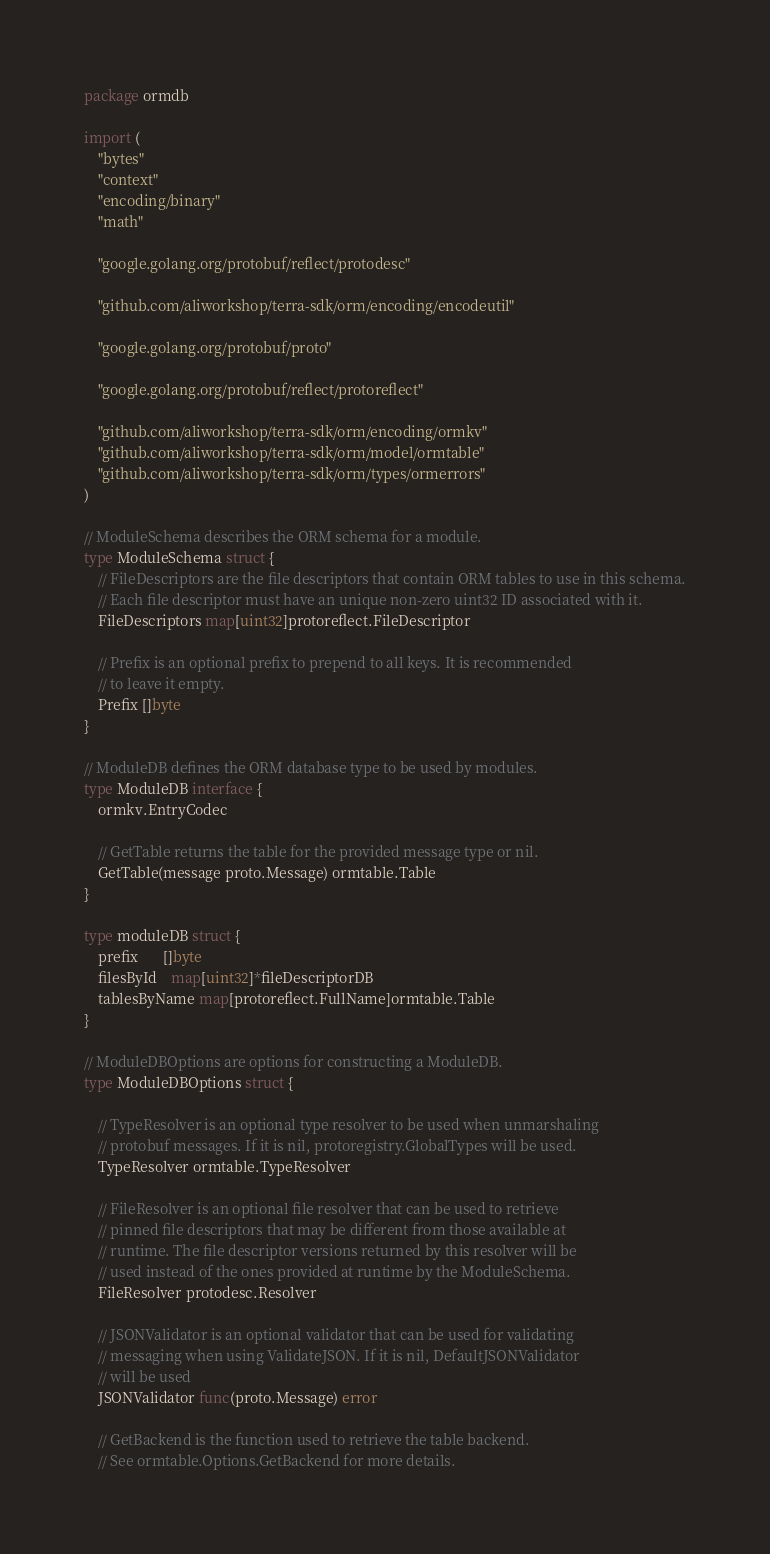<code> <loc_0><loc_0><loc_500><loc_500><_Go_>package ormdb

import (
	"bytes"
	"context"
	"encoding/binary"
	"math"

	"google.golang.org/protobuf/reflect/protodesc"

	"github.com/aliworkshop/terra-sdk/orm/encoding/encodeutil"

	"google.golang.org/protobuf/proto"

	"google.golang.org/protobuf/reflect/protoreflect"

	"github.com/aliworkshop/terra-sdk/orm/encoding/ormkv"
	"github.com/aliworkshop/terra-sdk/orm/model/ormtable"
	"github.com/aliworkshop/terra-sdk/orm/types/ormerrors"
)

// ModuleSchema describes the ORM schema for a module.
type ModuleSchema struct {
	// FileDescriptors are the file descriptors that contain ORM tables to use in this schema.
	// Each file descriptor must have an unique non-zero uint32 ID associated with it.
	FileDescriptors map[uint32]protoreflect.FileDescriptor

	// Prefix is an optional prefix to prepend to all keys. It is recommended
	// to leave it empty.
	Prefix []byte
}

// ModuleDB defines the ORM database type to be used by modules.
type ModuleDB interface {
	ormkv.EntryCodec

	// GetTable returns the table for the provided message type or nil.
	GetTable(message proto.Message) ormtable.Table
}

type moduleDB struct {
	prefix       []byte
	filesById    map[uint32]*fileDescriptorDB
	tablesByName map[protoreflect.FullName]ormtable.Table
}

// ModuleDBOptions are options for constructing a ModuleDB.
type ModuleDBOptions struct {

	// TypeResolver is an optional type resolver to be used when unmarshaling
	// protobuf messages. If it is nil, protoregistry.GlobalTypes will be used.
	TypeResolver ormtable.TypeResolver

	// FileResolver is an optional file resolver that can be used to retrieve
	// pinned file descriptors that may be different from those available at
	// runtime. The file descriptor versions returned by this resolver will be
	// used instead of the ones provided at runtime by the ModuleSchema.
	FileResolver protodesc.Resolver

	// JSONValidator is an optional validator that can be used for validating
	// messaging when using ValidateJSON. If it is nil, DefaultJSONValidator
	// will be used
	JSONValidator func(proto.Message) error

	// GetBackend is the function used to retrieve the table backend.
	// See ormtable.Options.GetBackend for more details.</code> 